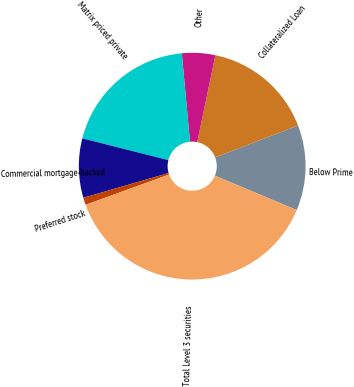Convert chart to OTSL. <chart><loc_0><loc_0><loc_500><loc_500><pie_chart><fcel>Below Prime<fcel>Collateralized Loan<fcel>Other<fcel>Matrix priced private<fcel>Commercial mortgage-backed<fcel>Preferred stock<fcel>Total Level 3 securities<nl><fcel>12.16%<fcel>15.88%<fcel>4.74%<fcel>19.59%<fcel>8.45%<fcel>1.03%<fcel>38.15%<nl></chart> 